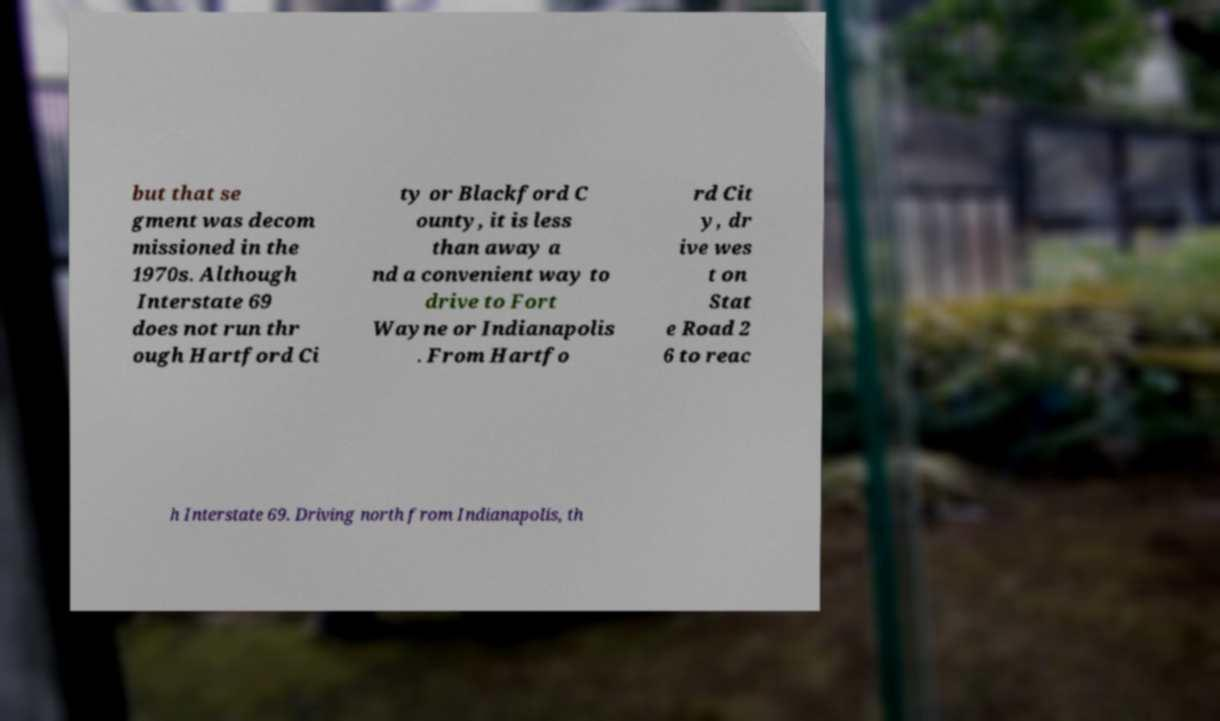I need the written content from this picture converted into text. Can you do that? but that se gment was decom missioned in the 1970s. Although Interstate 69 does not run thr ough Hartford Ci ty or Blackford C ounty, it is less than away a nd a convenient way to drive to Fort Wayne or Indianapolis . From Hartfo rd Cit y, dr ive wes t on Stat e Road 2 6 to reac h Interstate 69. Driving north from Indianapolis, th 